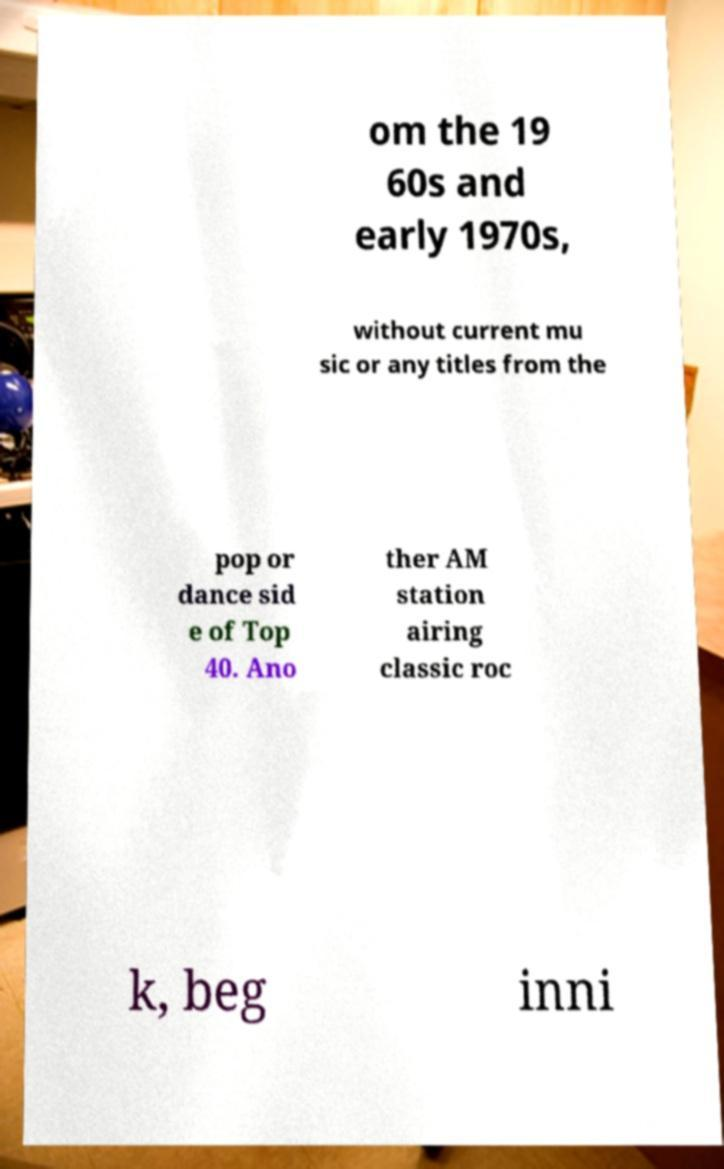Can you accurately transcribe the text from the provided image for me? om the 19 60s and early 1970s, without current mu sic or any titles from the pop or dance sid e of Top 40. Ano ther AM station airing classic roc k, beg inni 